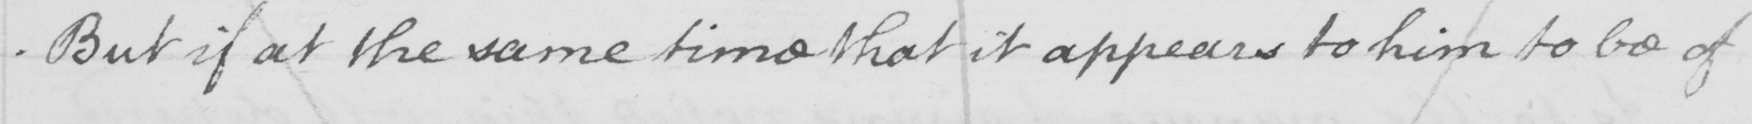Can you read and transcribe this handwriting? But if at the same time it appear to him to be of 